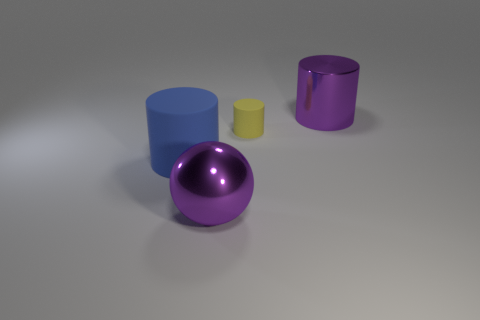What material is the large sphere that is the same color as the metal cylinder?
Provide a short and direct response. Metal. What size is the matte cylinder right of the big purple object left of the tiny yellow cylinder?
Offer a very short reply. Small. Does the purple thing behind the blue rubber thing have the same shape as the matte thing in front of the small yellow matte thing?
Provide a short and direct response. Yes. The thing that is in front of the tiny yellow thing and behind the purple shiny sphere is what color?
Your answer should be compact. Blue. Is there a large object of the same color as the big metal cylinder?
Provide a short and direct response. Yes. What color is the rubber object that is in front of the small cylinder?
Your answer should be compact. Blue. There is a purple metallic thing behind the yellow object; are there any big objects that are on the left side of it?
Provide a succinct answer. Yes. There is a large shiny cylinder; is its color the same as the large metallic thing in front of the purple metal cylinder?
Your answer should be compact. Yes. Is there a purple object that has the same material as the purple ball?
Offer a terse response. Yes. What number of tiny cyan metal blocks are there?
Offer a very short reply. 0. 